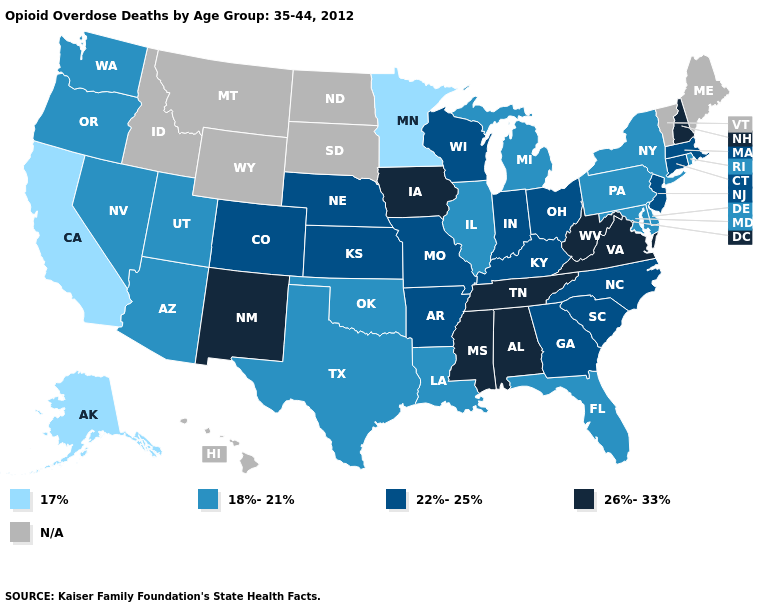Does the map have missing data?
Quick response, please. Yes. What is the value of Florida?
Concise answer only. 18%-21%. Among the states that border Missouri , which have the lowest value?
Answer briefly. Illinois, Oklahoma. What is the value of California?
Be succinct. 17%. What is the value of Wisconsin?
Quick response, please. 22%-25%. Among the states that border Arkansas , does Missouri have the highest value?
Quick response, please. No. Which states have the lowest value in the West?
Short answer required. Alaska, California. Among the states that border Tennessee , which have the lowest value?
Give a very brief answer. Arkansas, Georgia, Kentucky, Missouri, North Carolina. What is the value of Montana?
Answer briefly. N/A. What is the highest value in the USA?
Answer briefly. 26%-33%. Which states have the lowest value in the USA?
Quick response, please. Alaska, California, Minnesota. How many symbols are there in the legend?
Concise answer only. 5. Among the states that border Colorado , which have the highest value?
Write a very short answer. New Mexico. 